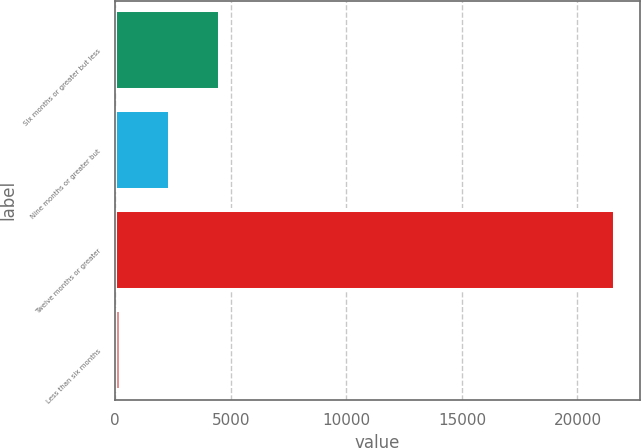<chart> <loc_0><loc_0><loc_500><loc_500><bar_chart><fcel>Six months or greater but less<fcel>Nine months or greater but<fcel>Twelve months or greater<fcel>Less than six months<nl><fcel>4523<fcel>2385<fcel>21627<fcel>247<nl></chart> 